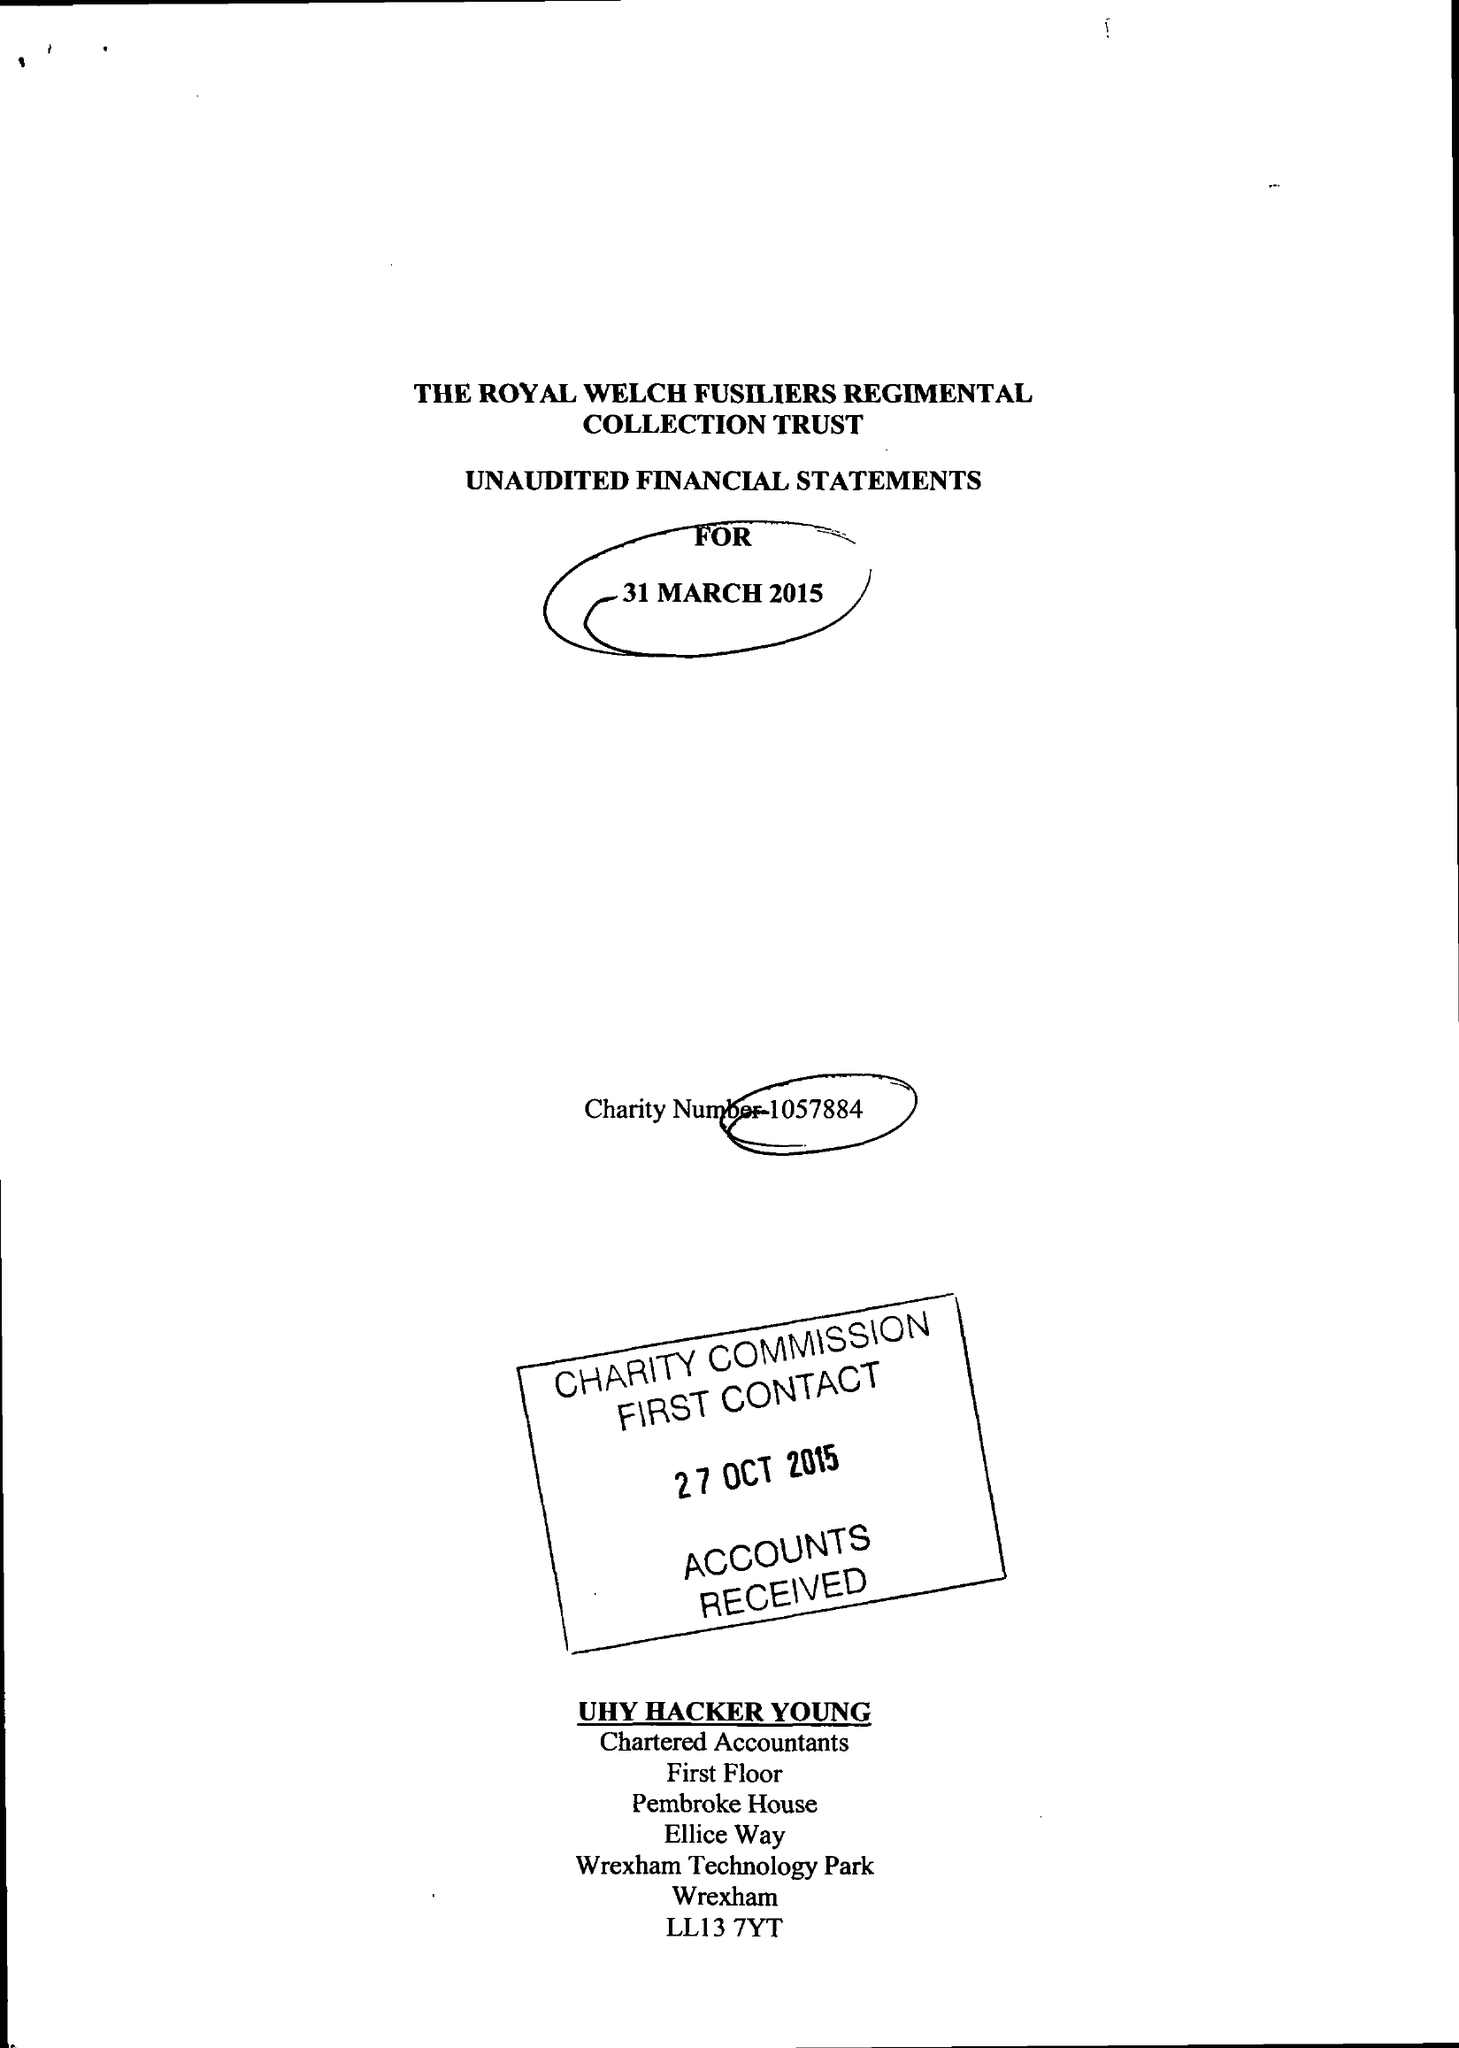What is the value for the address__street_line?
Answer the question using a single word or phrase. ELLICE WAY 